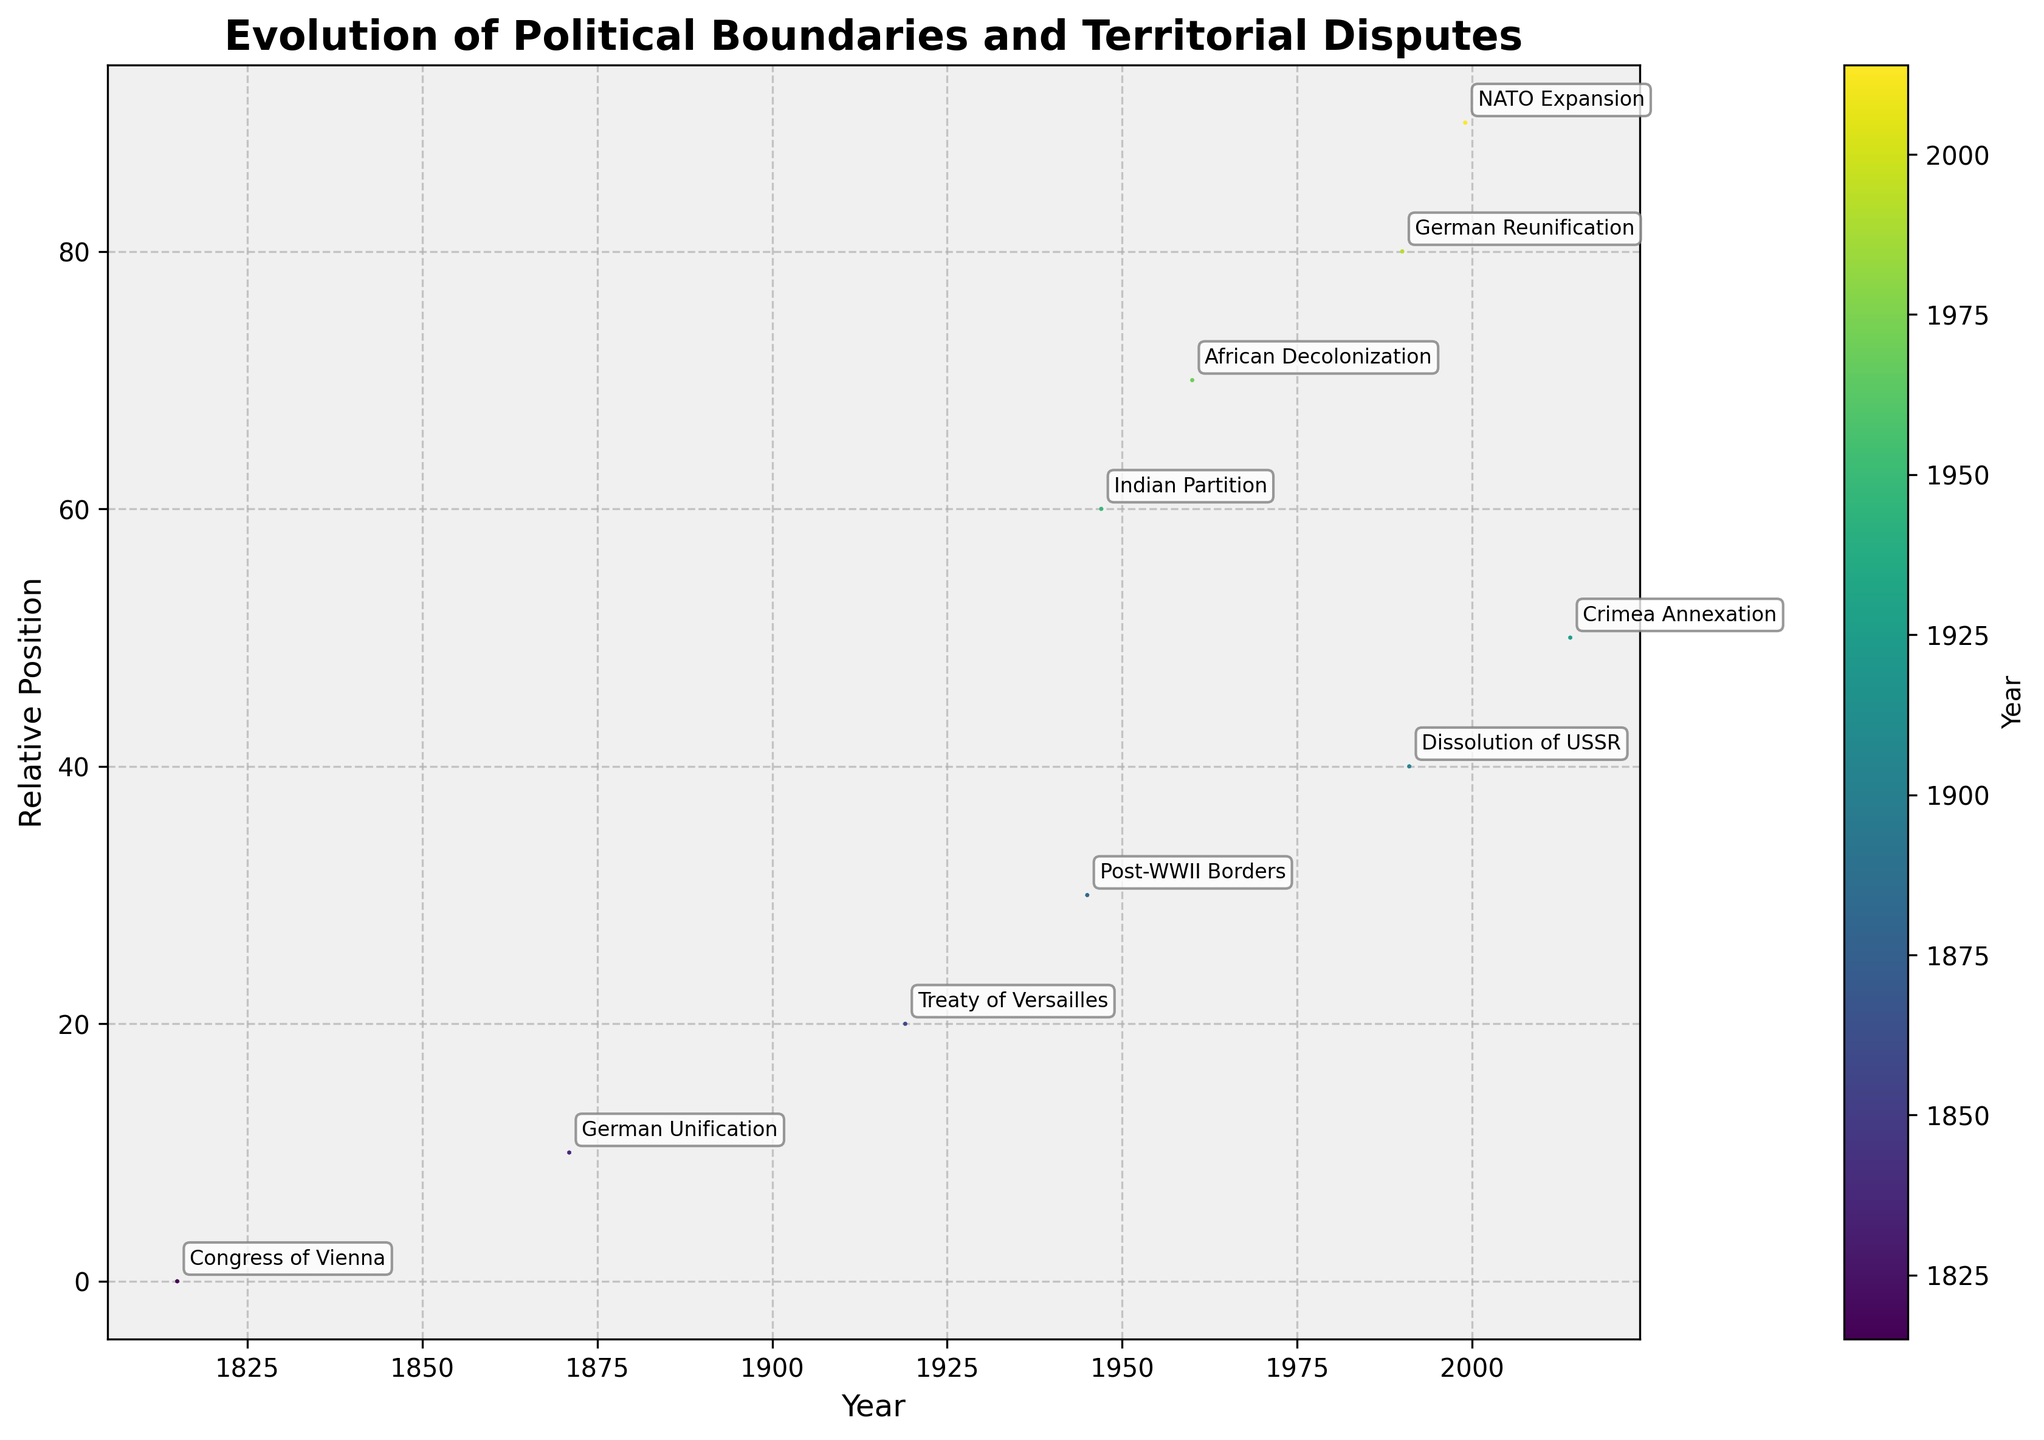What's the title of the plot? The title of the plot is displayed at the top of the figure and is usually larger in font size compared to other text on the plot. The title in this case is "Evolution of Political Boundaries and Territorial Disputes".
Answer: Evolution of Political Boundaries and Territorial Disputes How many political events are annotated in the figure? The plot displays arrows for each political event, with each labeled by text. By counting these labeled arrows, we can determine the number of annotated events. There are 10 labeled arrows/events.
Answer: 10 What event corresponds to the year 1991? To find the event for a specific year, locate the corresponding x-value on the horizontal axis. The label closest to the year 1991 is "Dissolution of USSR".
Answer: Dissolution of USSR Which event shows the longest arrow? The length of the arrow can be estimated by visually measuring the distance from the arrow's starting point to its end. The arrow for the "Dissolution of USSR" appears to be the longest.
Answer: Dissolution of USSR What are the start and end coordinates of the arrow labeled "Treaty of Versailles"? To find the coordinates, check the base of the arrow for the starting point (x, y) and the tip of the arrow for the ending coordinates, which is derived by adding u and v to the starting point. The starting coordinates are (20, 20), and with a movement of (-40, 30), the end coordinates are (-20, 50).
Answer: Start: (20, 20), End: (-20, 50) Which event represents a significant upward shift in position? An upward shift in position indicates a positive change in the y-direction. The "Treaty of Versailles" shows a significant upward shift with a v-value of 30.
Answer: Treaty of Versailles Which two events happen closest in time? To determine this, find the events with the smallest difference in x-values. The events "2014 Crimea Annexation" and "1999 NATO Expansion" have the smallest gap of 15 years (difference in x-values of 50 and 90).
Answer: Crimea Annexation (2014) and NATO Expansion (1999) What general pattern do you observe in the directional changes of the arrows over time? Observing the directions of arrows over time from left to right on the plot can show if there is a pattern in territorial disputes and boundary evolution. There are mixed directions indicating various territorial changes, but many arrows in the mid-range (20 to 40 years) show significant territorial shifts possibly related to post-war adjustments.
Answer: Mixed directions Does the figure include any events related to the African continent? To find this information, look at the labels of the events for any reference to African geopolitical changes. "African Decolonization" labeled in 1960 is related to the African continent.
Answer: Yes, "African Decolonization" 